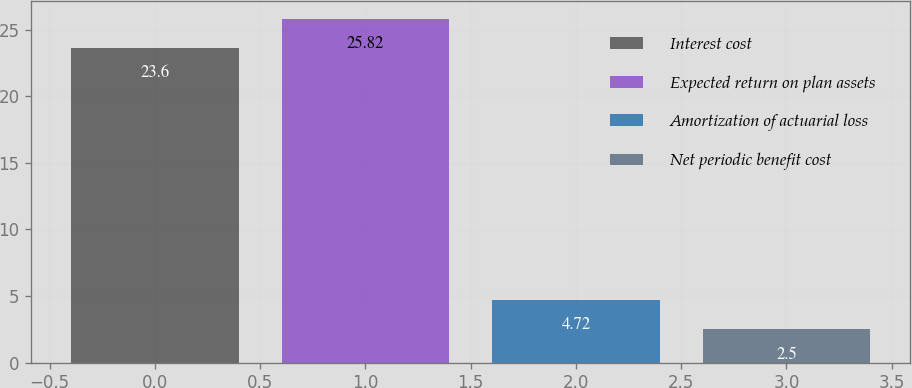<chart> <loc_0><loc_0><loc_500><loc_500><bar_chart><fcel>Interest cost<fcel>Expected return on plan assets<fcel>Amortization of actuarial loss<fcel>Net periodic benefit cost<nl><fcel>23.6<fcel>25.82<fcel>4.72<fcel>2.5<nl></chart> 